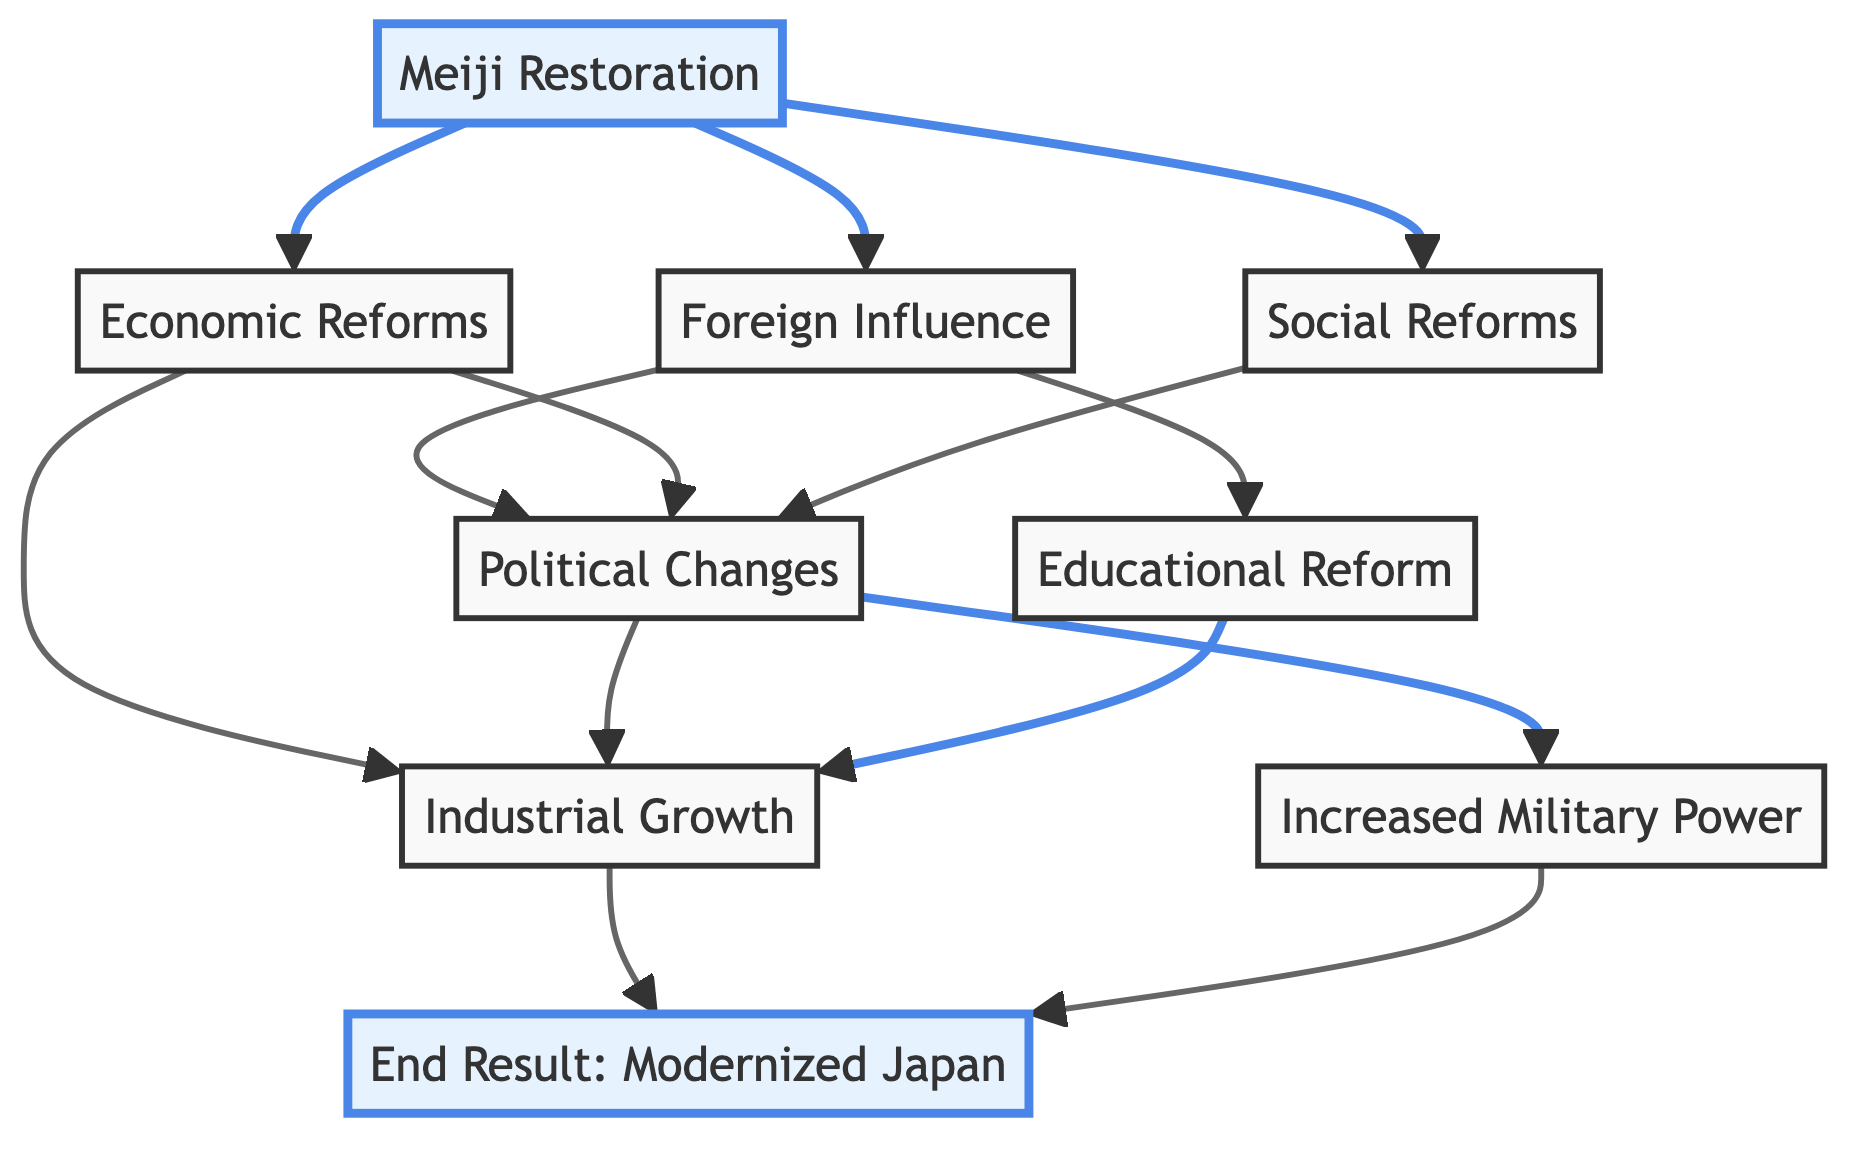What is the starting point of the flowchart? The flowchart begins with the node labeled "Meiji Restoration," which represents the initiation of changes in Japan under Emperor Meiji in 1868.
Answer: Meiji Restoration How many main outcomes lead to the "End Result: Modernized Japan"? The diagram shows three main outcomes that contribute to the end result: "Increased Military Power," "Industrial Growth," and "Educational Reform."
Answer: Three What connects "Foreign Influence" to "Political Changes"? "Foreign Influence" is a precursor to "Political Changes," as it illustrates the impact of Western ideas and practices on Japan's political transformation.
Answer: Foreign Influence Which element directly influences both "Economic Reforms" and "Social Reforms"? The "Meiji Restoration" influences both "Economic Reforms" and "Social Reforms," illustrating how the restoration was fundamental to these aspects of modernization.
Answer: Meiji Restoration How does "Educational Reform" affect the modernization process? "Educational Reform" leads to "Industrial Growth," showing that improvements in education contributed directly to the industrial advancement of Japan.
Answer: Industrial Growth What is the relationship between "Increased Military Power" and the end result? "Increased Military Power" is an influencing factor that ultimately supports the "End Result: Modernized Japan," emphasizing how military enhancement contributed to Japan's modernization.
Answer: End Result: Modernized Japan Which node has the most connections leading to it? The node "Industrial Growth" shows the most connections, being influenced by "Economic Reforms," "Political Changes," and "Educational Reform," indicating its central role in the modernization process.
Answer: Industrial Growth How many elements are represented in the flowchart? The flowchart includes a total of nine elements, consisting of the starting point, various influences, and the end result.
Answer: Nine What does the highlighted portion of the flowchart signify? The highlighted sections represent the "Meiji Restoration" and the "End Result: Modernized Japan," emphasizing their importance as the starting point and conclusion of the modernization process.
Answer: Meiji Restoration, End Result: Modernized Japan 